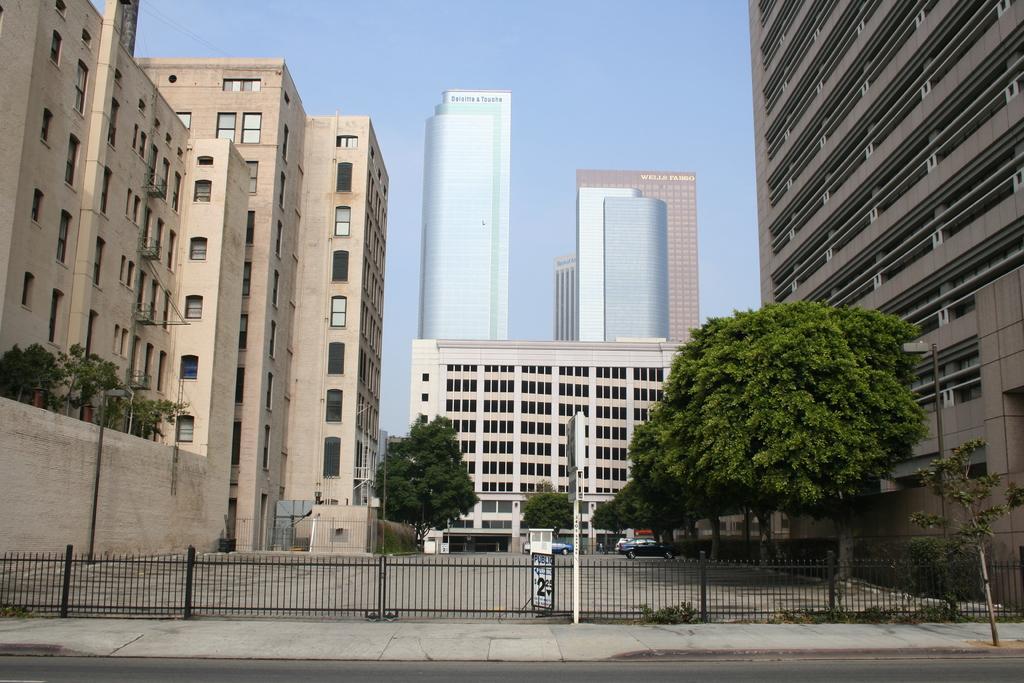In one or two sentences, can you explain what this image depicts? In this image, we can see some trees in between buildings. There is a fencing at the bottom of the image. There is a building in the middle of the image. In the background of the image, there is a sky. 